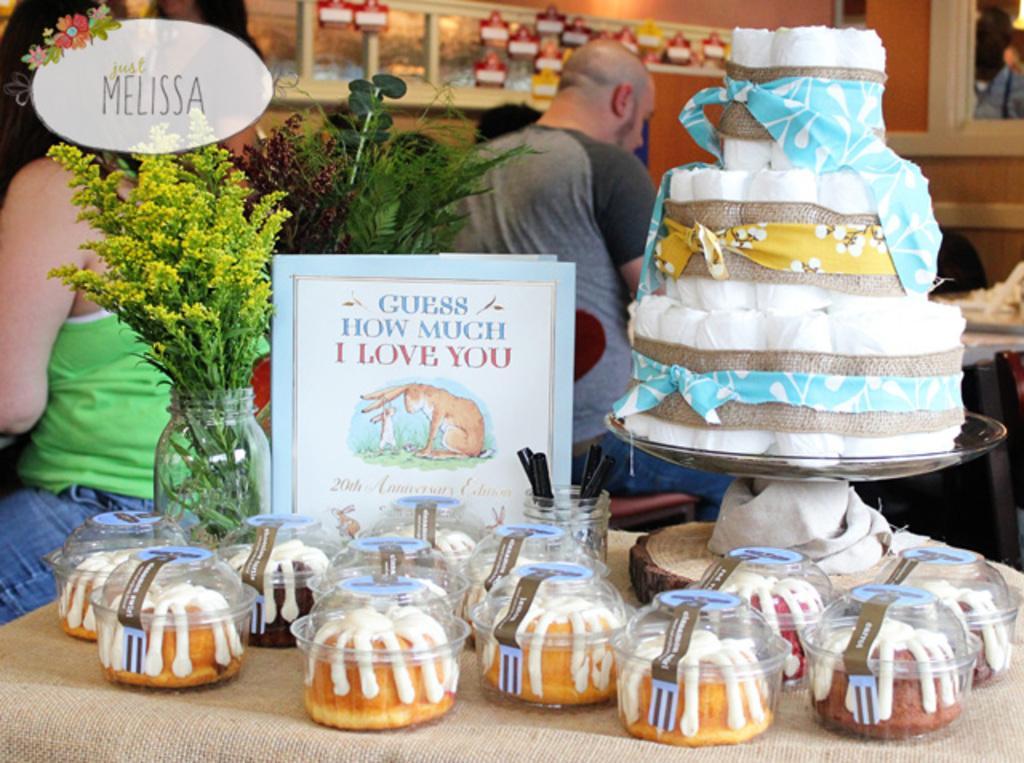How would you summarize this image in a sentence or two? In this image we can see a table containing a cake in a plate, flower pot, board, some pens in a glass and some cakes in the bowls. On the backside we can see a man and a woman sitting on the chairs. 